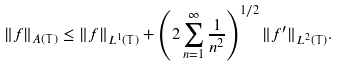<formula> <loc_0><loc_0><loc_500><loc_500>\| f \| _ { A ( \mathbb { T } ) } \leq \| f \| _ { L ^ { 1 } ( \mathbb { T } ) } + \left ( 2 \sum _ { n = 1 } ^ { \infty } \frac { 1 } { n ^ { 2 } } \right ) ^ { 1 / 2 } \| f ^ { \prime } \| _ { L ^ { 2 } ( \mathbb { T } ) } .</formula> 